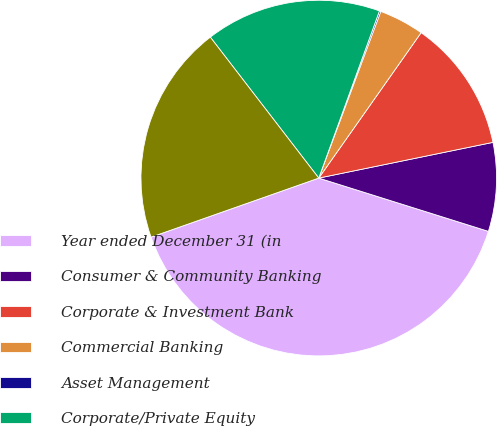Convert chart to OTSL. <chart><loc_0><loc_0><loc_500><loc_500><pie_chart><fcel>Year ended December 31 (in<fcel>Consumer & Community Banking<fcel>Corporate & Investment Bank<fcel>Commercial Banking<fcel>Asset Management<fcel>Corporate/Private Equity<fcel>Total common stockholders'<nl><fcel>39.77%<fcel>8.06%<fcel>12.02%<fcel>4.09%<fcel>0.13%<fcel>15.98%<fcel>19.95%<nl></chart> 